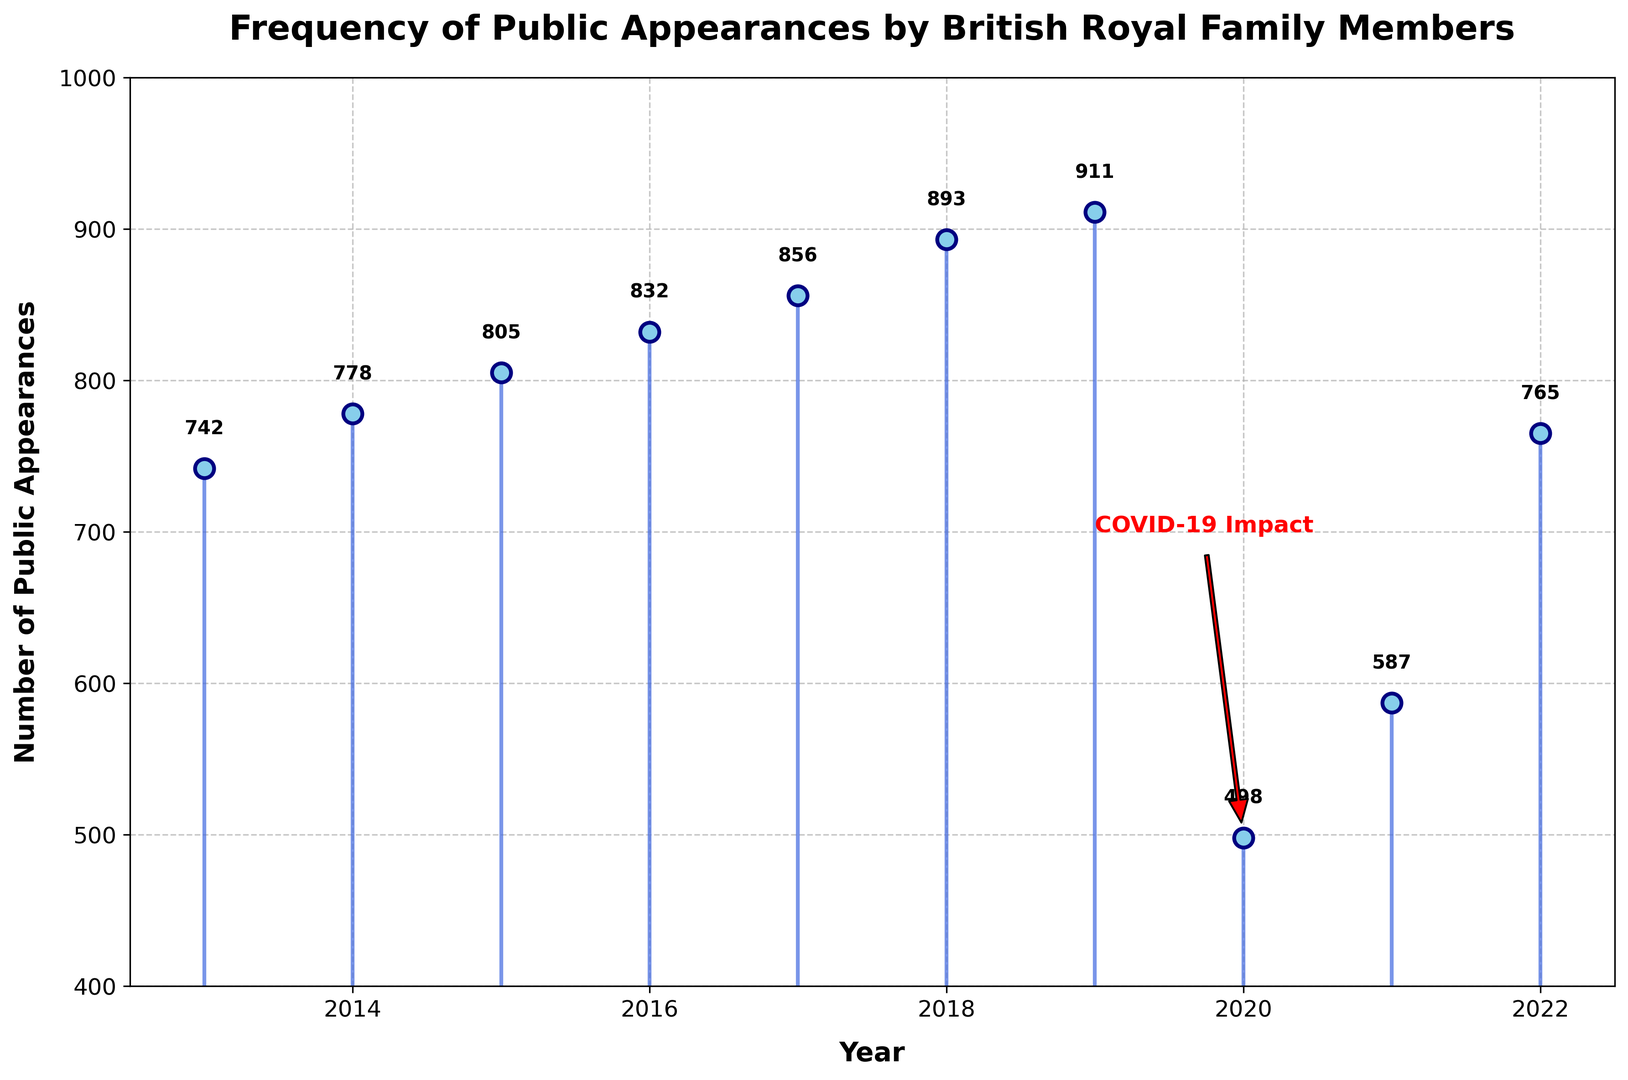What was the trend in the number of public appearances from 2013 to 2019? From 2013 to 2019, the number of public appearances shows a steady increase each year. The appearances rise from 742 in 2013 to 911 in 2019, indicating a consistent upward trend during this period.
Answer: Steady increase What year had the highest number of public appearances and what was the count? By looking at the data points on the stem plot, the year 2019 had the highest number of public appearances, with a count of 911.
Answer: 2019, 911 How did the number of public appearances change from 2019 to 2020? There is a significant drop from 911 appearances in 2019 to 498 in 2020, indicating a large decrease, likely due to the impact of COVID-19, as annotated in the plot.
Answer: Decreased significantly In which years did the number of public appearances exceed 800? The years where public appearances exceeded 800 are 2015 (805), 2016 (832), 2017 (856), 2018 (893), and 2019 (911).
Answer: 2015, 2016, 2017, 2018, 2019 What is the average number of public appearances from 2013 to 2019? Adding the numbers from 2013 to 2019: 742 + 778 + 805 + 832 + 856 + 893 + 911 = 5817. There are 7 years, so the average is 5817 / 7 = 831.
Answer: 831 What impact did COVID-19 have on public appearances in 2020? In 2020, the number of public appearances dropped significantly to 498, which is highlighted in the plot with an annotation pointing out the 'COVID-19 Impact'. This shows how the pandemic affected their public engagements.
Answer: Significant decrease By how much did the number of public appearances change from 2021 to 2022? The number of appearances rose from 587 in 2021 to 765 in 2022. The difference is 765 - 587 = 178.
Answer: Increase by 178 Compare the number of public appearances in 2017 and 2022. Which year had higher appearances and by how much? The number of public appearances in 2017 was 856, while in 2022 it was 765. Therefore, 2017 had 856 - 765 = 91 more appearances than 2022.
Answer: 2017 had 91 more What is the overall range (difference between the highest and lowest values) of public appearances over the decade? The highest number of appearances was 911 in 2019, and the lowest was 498 in 2020. The range is 911 - 498 = 413.
Answer: 413 